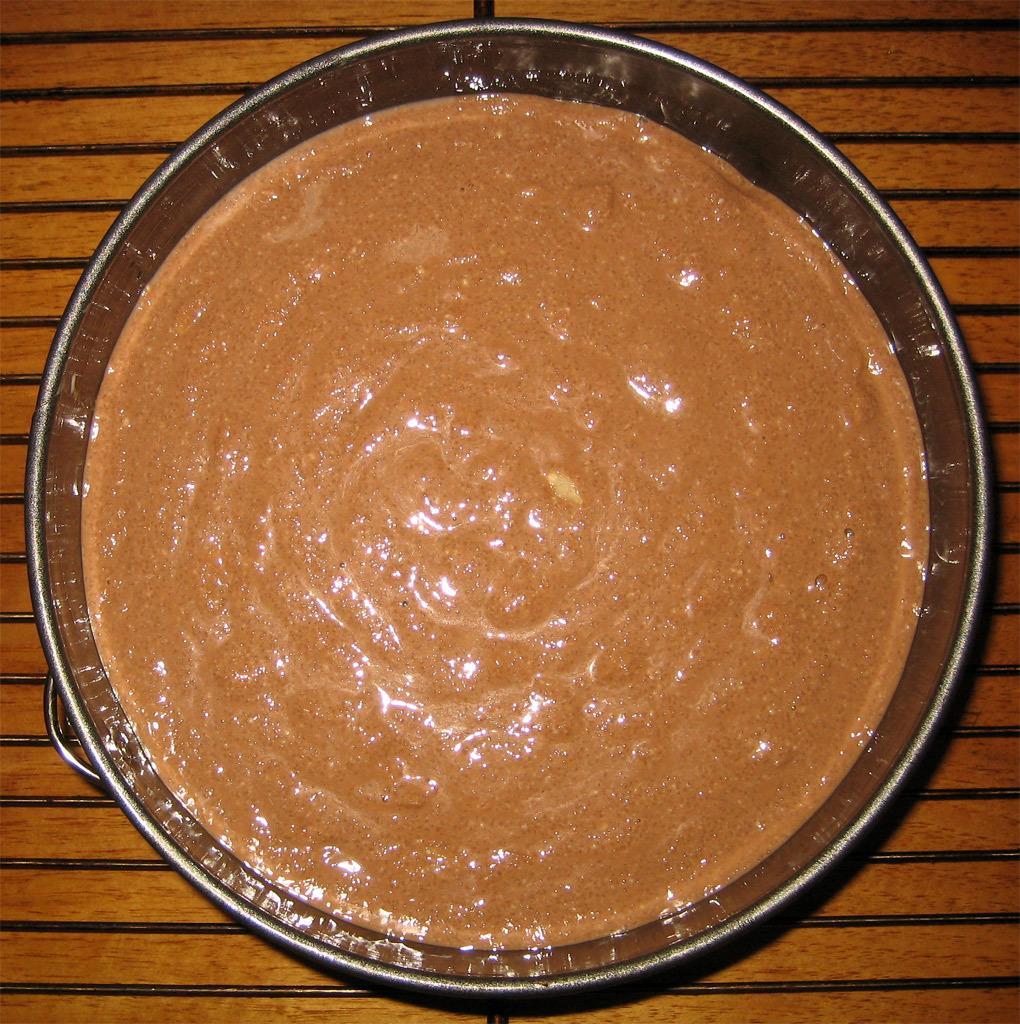Could you give a brief overview of what you see in this image? In this picture we can see a bowl here, we can see something present in the bowl, at the bottom there is a wooden surface. 